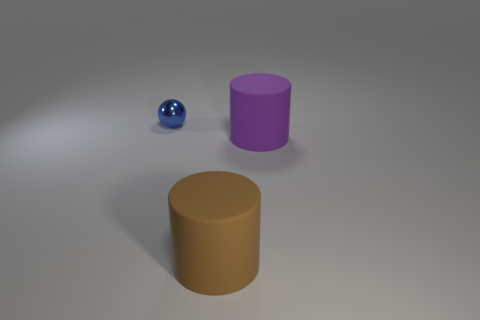Is the size of the cylinder that is right of the brown object the same as the tiny object?
Provide a succinct answer. No. What shape is the tiny object?
Offer a very short reply. Sphere. Are the big object that is on the left side of the big purple matte cylinder and the small blue thing made of the same material?
Your answer should be very brief. No. Are there any other spheres that have the same color as the small metal ball?
Offer a terse response. No. Do the matte thing to the left of the big purple matte object and the large object on the right side of the brown object have the same shape?
Your answer should be compact. Yes. Is there a large yellow object made of the same material as the big purple cylinder?
Keep it short and to the point. No. How many cyan objects are either tiny objects or cylinders?
Give a very brief answer. 0. What size is the object that is on the left side of the large purple matte thing and right of the small thing?
Your answer should be compact. Large. Are there more blue metal objects right of the large brown cylinder than big brown cylinders?
Your answer should be compact. No. What number of cylinders are brown things or large purple matte things?
Offer a terse response. 2. 